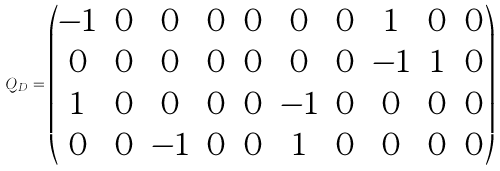Convert formula to latex. <formula><loc_0><loc_0><loc_500><loc_500>Q _ { D } = \begin{pmatrix} - 1 & 0 & 0 & 0 & 0 & 0 & 0 & 1 & 0 & 0 \\ 0 & 0 & 0 & 0 & 0 & 0 & 0 & - 1 & 1 & 0 \\ 1 & 0 & 0 & 0 & 0 & - 1 & 0 & 0 & 0 & 0 \\ 0 & 0 & - 1 & 0 & 0 & 1 & 0 & 0 & 0 & 0 \end{pmatrix}</formula> 